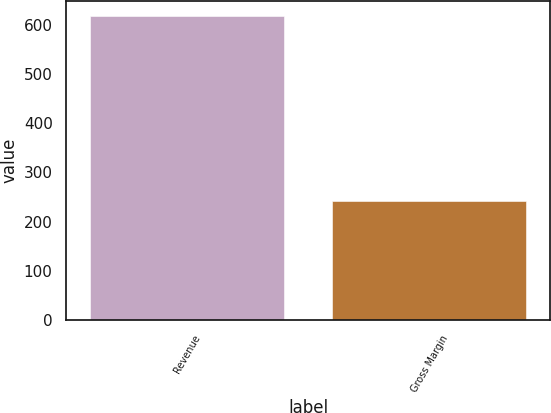<chart> <loc_0><loc_0><loc_500><loc_500><bar_chart><fcel>Revenue<fcel>Gross Margin<nl><fcel>618<fcel>241<nl></chart> 